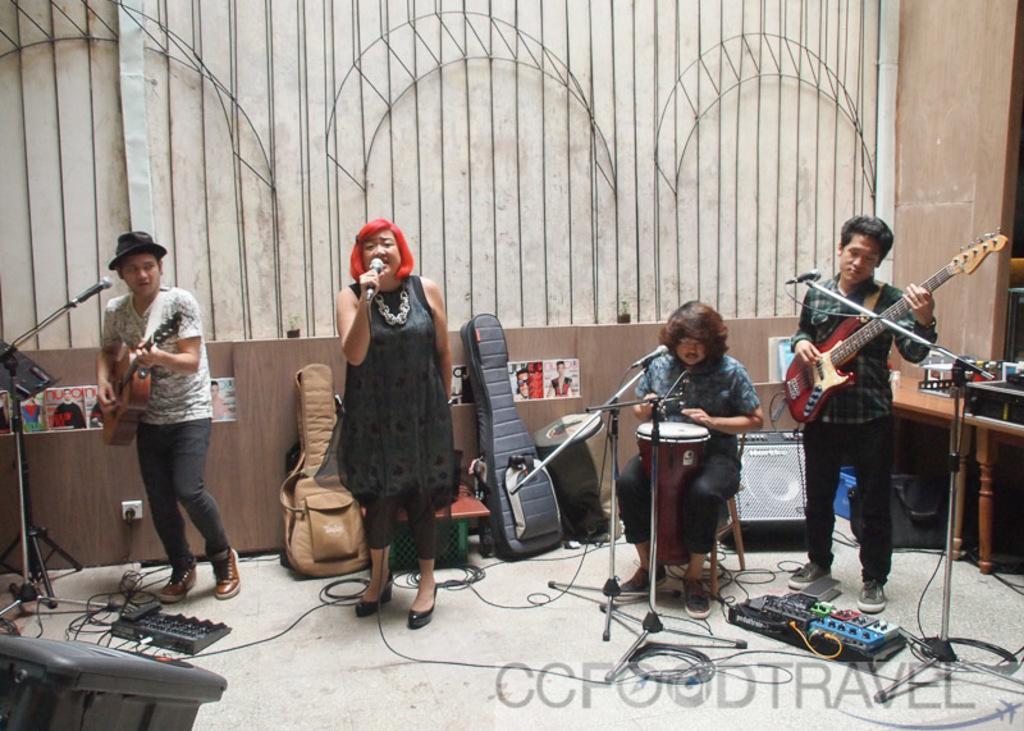Can you describe this image briefly? In this image there is a woman standing and singing a song in the microphone , another man standing and playing a guitar , another man standing and playing a guitar , another man sitting and playing the drums , in the back ground there are guitar bags , cables , speakers , table , and some iron grills. 